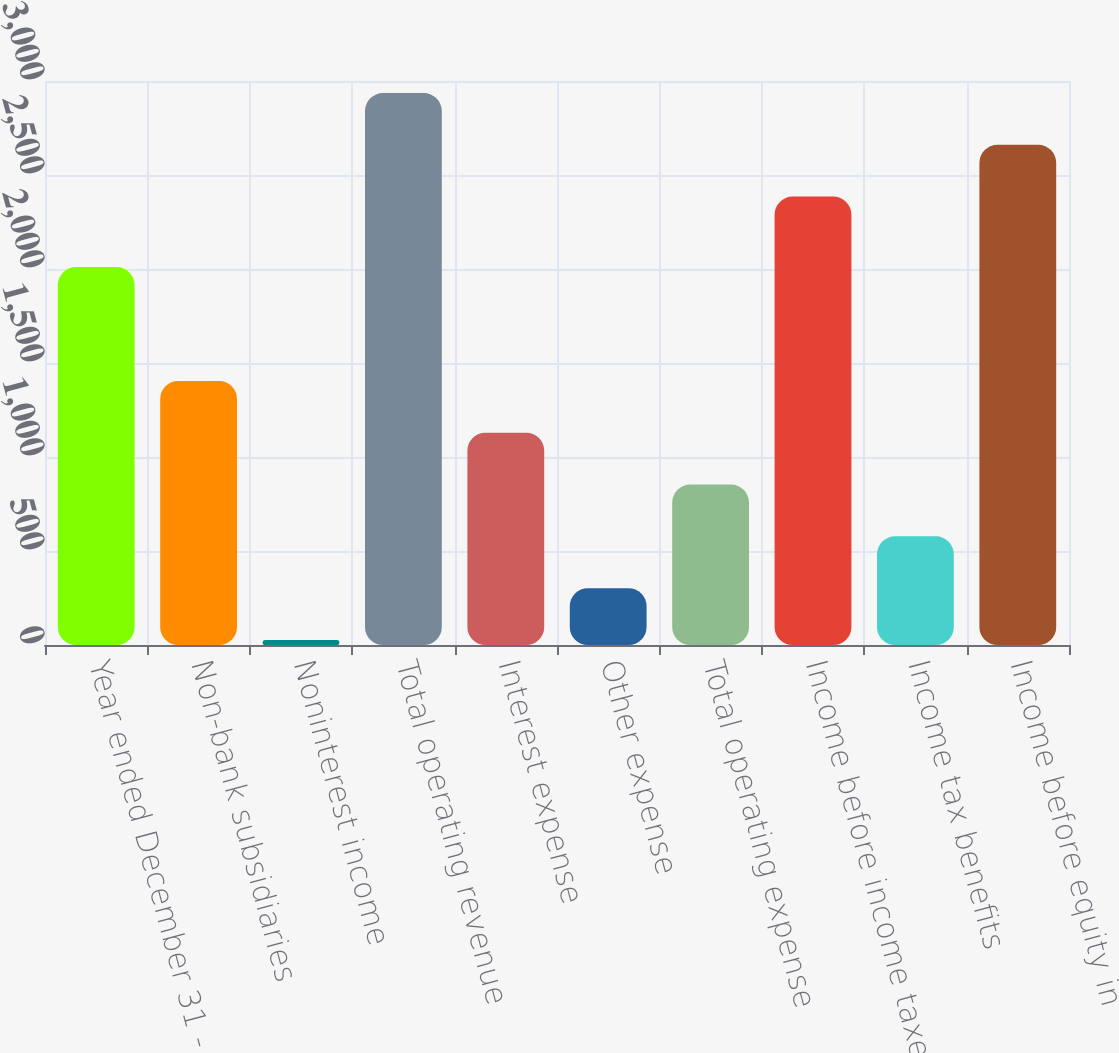Convert chart. <chart><loc_0><loc_0><loc_500><loc_500><bar_chart><fcel>Year ended December 31 - in<fcel>Non-bank subsidiaries<fcel>Noninterest income<fcel>Total operating revenue<fcel>Interest expense<fcel>Other expense<fcel>Total operating expense<fcel>Income before income taxes and<fcel>Income tax benefits<fcel>Income before equity in<nl><fcel>2010<fcel>1404.5<fcel>27<fcel>2936<fcel>1129<fcel>302.5<fcel>853.5<fcel>2385<fcel>578<fcel>2660.5<nl></chart> 